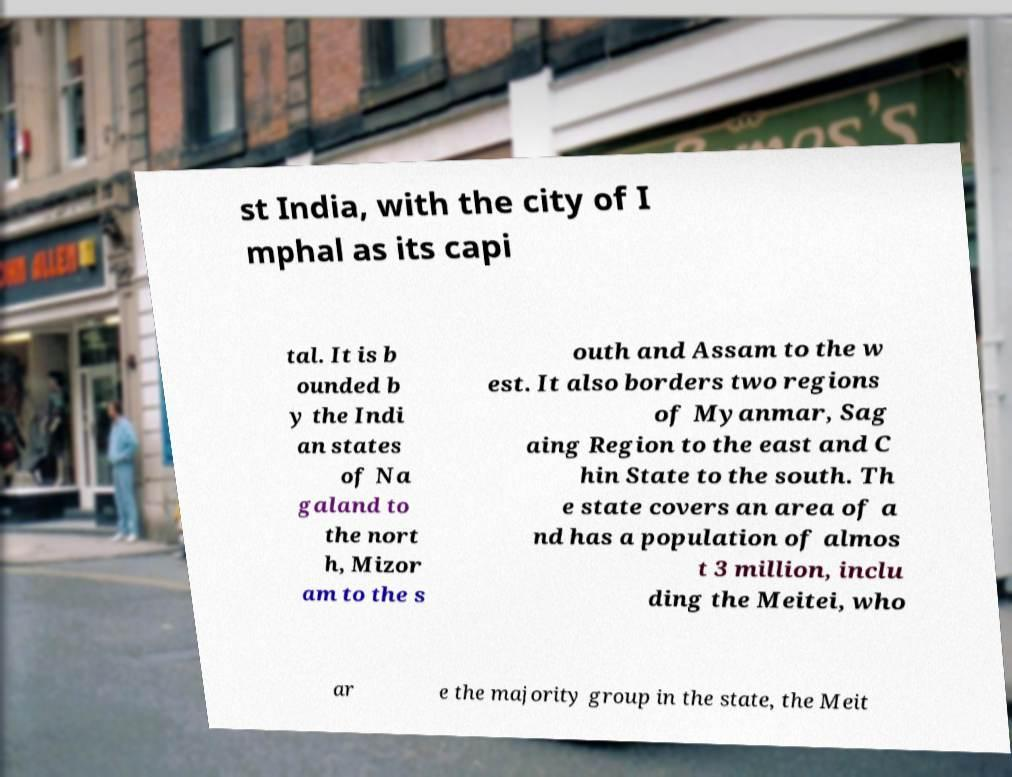For documentation purposes, I need the text within this image transcribed. Could you provide that? st India, with the city of I mphal as its capi tal. It is b ounded b y the Indi an states of Na galand to the nort h, Mizor am to the s outh and Assam to the w est. It also borders two regions of Myanmar, Sag aing Region to the east and C hin State to the south. Th e state covers an area of a nd has a population of almos t 3 million, inclu ding the Meitei, who ar e the majority group in the state, the Meit 